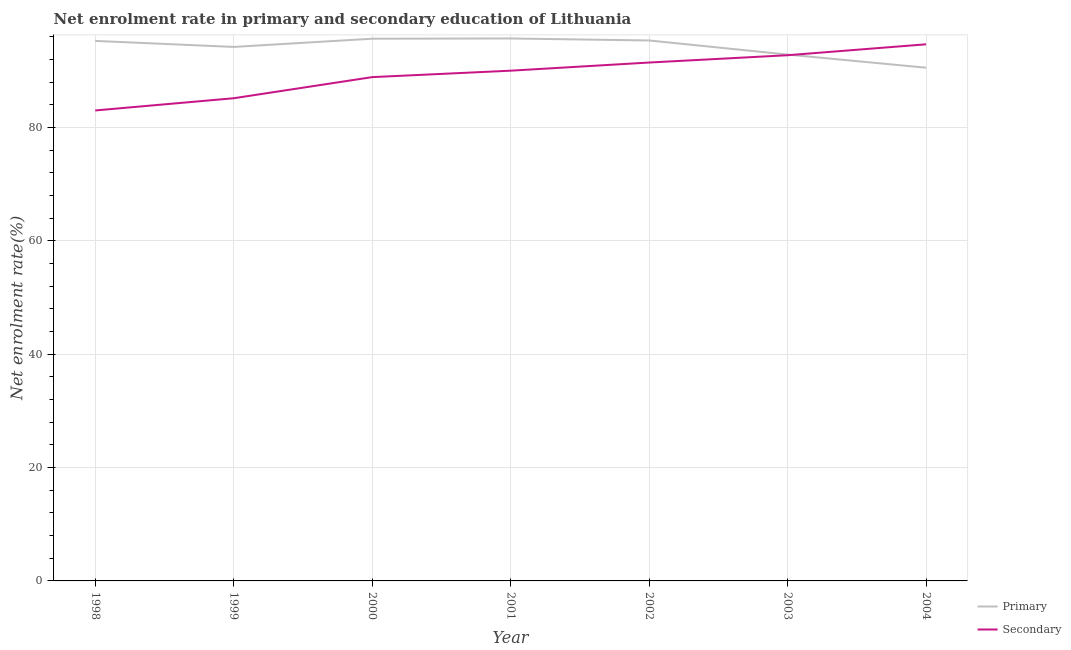Does the line corresponding to enrollment rate in primary education intersect with the line corresponding to enrollment rate in secondary education?
Give a very brief answer. Yes. Is the number of lines equal to the number of legend labels?
Keep it short and to the point. Yes. What is the enrollment rate in primary education in 2004?
Ensure brevity in your answer.  90.56. Across all years, what is the maximum enrollment rate in primary education?
Make the answer very short. 95.72. Across all years, what is the minimum enrollment rate in secondary education?
Your answer should be very brief. 83.02. In which year was the enrollment rate in primary education minimum?
Make the answer very short. 2004. What is the total enrollment rate in primary education in the graph?
Your answer should be very brief. 659.71. What is the difference between the enrollment rate in secondary education in 1999 and that in 2003?
Make the answer very short. -7.59. What is the difference between the enrollment rate in primary education in 1999 and the enrollment rate in secondary education in 2003?
Give a very brief answer. 1.46. What is the average enrollment rate in secondary education per year?
Make the answer very short. 89.44. In the year 1998, what is the difference between the enrollment rate in primary education and enrollment rate in secondary education?
Your answer should be very brief. 12.27. In how many years, is the enrollment rate in secondary education greater than 12 %?
Your response must be concise. 7. What is the ratio of the enrollment rate in primary education in 1998 to that in 1999?
Your answer should be compact. 1.01. Is the enrollment rate in secondary education in 2001 less than that in 2003?
Offer a very short reply. Yes. What is the difference between the highest and the second highest enrollment rate in secondary education?
Give a very brief answer. 1.93. What is the difference between the highest and the lowest enrollment rate in primary education?
Provide a short and direct response. 5.16. In how many years, is the enrollment rate in primary education greater than the average enrollment rate in primary education taken over all years?
Give a very brief answer. 4. Is the sum of the enrollment rate in secondary education in 2000 and 2004 greater than the maximum enrollment rate in primary education across all years?
Provide a succinct answer. Yes. Is the enrollment rate in secondary education strictly greater than the enrollment rate in primary education over the years?
Offer a terse response. No. Is the enrollment rate in secondary education strictly less than the enrollment rate in primary education over the years?
Your response must be concise. No. How many lines are there?
Offer a terse response. 2. How many years are there in the graph?
Give a very brief answer. 7. What is the difference between two consecutive major ticks on the Y-axis?
Offer a terse response. 20. Are the values on the major ticks of Y-axis written in scientific E-notation?
Provide a succinct answer. No. Does the graph contain any zero values?
Your answer should be very brief. No. How many legend labels are there?
Your answer should be compact. 2. What is the title of the graph?
Your answer should be very brief. Net enrolment rate in primary and secondary education of Lithuania. What is the label or title of the X-axis?
Give a very brief answer. Year. What is the label or title of the Y-axis?
Offer a terse response. Net enrolment rate(%). What is the Net enrolment rate(%) of Primary in 1998?
Give a very brief answer. 95.29. What is the Net enrolment rate(%) of Secondary in 1998?
Give a very brief answer. 83.02. What is the Net enrolment rate(%) of Primary in 1999?
Provide a short and direct response. 94.23. What is the Net enrolment rate(%) of Secondary in 1999?
Your answer should be compact. 85.17. What is the Net enrolment rate(%) of Primary in 2000?
Offer a very short reply. 95.68. What is the Net enrolment rate(%) of Secondary in 2000?
Keep it short and to the point. 88.9. What is the Net enrolment rate(%) of Primary in 2001?
Your response must be concise. 95.72. What is the Net enrolment rate(%) in Secondary in 2001?
Your response must be concise. 90.03. What is the Net enrolment rate(%) of Primary in 2002?
Your answer should be very brief. 95.37. What is the Net enrolment rate(%) in Secondary in 2002?
Offer a terse response. 91.47. What is the Net enrolment rate(%) in Primary in 2003?
Your answer should be compact. 92.88. What is the Net enrolment rate(%) of Secondary in 2003?
Offer a very short reply. 92.76. What is the Net enrolment rate(%) of Primary in 2004?
Offer a very short reply. 90.56. What is the Net enrolment rate(%) in Secondary in 2004?
Your answer should be compact. 94.69. Across all years, what is the maximum Net enrolment rate(%) in Primary?
Make the answer very short. 95.72. Across all years, what is the maximum Net enrolment rate(%) of Secondary?
Keep it short and to the point. 94.69. Across all years, what is the minimum Net enrolment rate(%) of Primary?
Your answer should be compact. 90.56. Across all years, what is the minimum Net enrolment rate(%) of Secondary?
Keep it short and to the point. 83.02. What is the total Net enrolment rate(%) in Primary in the graph?
Your response must be concise. 659.71. What is the total Net enrolment rate(%) of Secondary in the graph?
Your answer should be compact. 626.05. What is the difference between the Net enrolment rate(%) in Primary in 1998 and that in 1999?
Ensure brevity in your answer.  1.06. What is the difference between the Net enrolment rate(%) of Secondary in 1998 and that in 1999?
Offer a terse response. -2.16. What is the difference between the Net enrolment rate(%) in Primary in 1998 and that in 2000?
Ensure brevity in your answer.  -0.39. What is the difference between the Net enrolment rate(%) in Secondary in 1998 and that in 2000?
Offer a very short reply. -5.88. What is the difference between the Net enrolment rate(%) in Primary in 1998 and that in 2001?
Offer a very short reply. -0.43. What is the difference between the Net enrolment rate(%) in Secondary in 1998 and that in 2001?
Give a very brief answer. -7.02. What is the difference between the Net enrolment rate(%) of Primary in 1998 and that in 2002?
Your answer should be very brief. -0.08. What is the difference between the Net enrolment rate(%) in Secondary in 1998 and that in 2002?
Provide a succinct answer. -8.46. What is the difference between the Net enrolment rate(%) in Primary in 1998 and that in 2003?
Keep it short and to the point. 2.41. What is the difference between the Net enrolment rate(%) in Secondary in 1998 and that in 2003?
Ensure brevity in your answer.  -9.75. What is the difference between the Net enrolment rate(%) in Primary in 1998 and that in 2004?
Your answer should be very brief. 4.73. What is the difference between the Net enrolment rate(%) of Secondary in 1998 and that in 2004?
Provide a short and direct response. -11.67. What is the difference between the Net enrolment rate(%) in Primary in 1999 and that in 2000?
Offer a very short reply. -1.45. What is the difference between the Net enrolment rate(%) of Secondary in 1999 and that in 2000?
Provide a short and direct response. -3.73. What is the difference between the Net enrolment rate(%) of Primary in 1999 and that in 2001?
Ensure brevity in your answer.  -1.49. What is the difference between the Net enrolment rate(%) of Secondary in 1999 and that in 2001?
Make the answer very short. -4.86. What is the difference between the Net enrolment rate(%) of Primary in 1999 and that in 2002?
Your answer should be very brief. -1.14. What is the difference between the Net enrolment rate(%) of Secondary in 1999 and that in 2002?
Offer a terse response. -6.3. What is the difference between the Net enrolment rate(%) of Primary in 1999 and that in 2003?
Make the answer very short. 1.35. What is the difference between the Net enrolment rate(%) in Secondary in 1999 and that in 2003?
Ensure brevity in your answer.  -7.59. What is the difference between the Net enrolment rate(%) of Primary in 1999 and that in 2004?
Your answer should be very brief. 3.66. What is the difference between the Net enrolment rate(%) in Secondary in 1999 and that in 2004?
Keep it short and to the point. -9.52. What is the difference between the Net enrolment rate(%) in Primary in 2000 and that in 2001?
Provide a short and direct response. -0.04. What is the difference between the Net enrolment rate(%) in Secondary in 2000 and that in 2001?
Ensure brevity in your answer.  -1.14. What is the difference between the Net enrolment rate(%) in Primary in 2000 and that in 2002?
Your answer should be compact. 0.31. What is the difference between the Net enrolment rate(%) of Secondary in 2000 and that in 2002?
Your answer should be very brief. -2.57. What is the difference between the Net enrolment rate(%) of Primary in 2000 and that in 2003?
Provide a short and direct response. 2.8. What is the difference between the Net enrolment rate(%) in Secondary in 2000 and that in 2003?
Offer a terse response. -3.86. What is the difference between the Net enrolment rate(%) in Primary in 2000 and that in 2004?
Offer a terse response. 5.11. What is the difference between the Net enrolment rate(%) in Secondary in 2000 and that in 2004?
Ensure brevity in your answer.  -5.79. What is the difference between the Net enrolment rate(%) in Primary in 2001 and that in 2002?
Offer a very short reply. 0.35. What is the difference between the Net enrolment rate(%) in Secondary in 2001 and that in 2002?
Offer a terse response. -1.44. What is the difference between the Net enrolment rate(%) in Primary in 2001 and that in 2003?
Your answer should be compact. 2.84. What is the difference between the Net enrolment rate(%) in Secondary in 2001 and that in 2003?
Provide a short and direct response. -2.73. What is the difference between the Net enrolment rate(%) in Primary in 2001 and that in 2004?
Give a very brief answer. 5.16. What is the difference between the Net enrolment rate(%) of Secondary in 2001 and that in 2004?
Your response must be concise. -4.65. What is the difference between the Net enrolment rate(%) in Primary in 2002 and that in 2003?
Your answer should be very brief. 2.49. What is the difference between the Net enrolment rate(%) of Secondary in 2002 and that in 2003?
Your response must be concise. -1.29. What is the difference between the Net enrolment rate(%) in Primary in 2002 and that in 2004?
Give a very brief answer. 4.8. What is the difference between the Net enrolment rate(%) in Secondary in 2002 and that in 2004?
Provide a short and direct response. -3.22. What is the difference between the Net enrolment rate(%) of Primary in 2003 and that in 2004?
Provide a short and direct response. 2.32. What is the difference between the Net enrolment rate(%) in Secondary in 2003 and that in 2004?
Give a very brief answer. -1.93. What is the difference between the Net enrolment rate(%) of Primary in 1998 and the Net enrolment rate(%) of Secondary in 1999?
Offer a terse response. 10.11. What is the difference between the Net enrolment rate(%) in Primary in 1998 and the Net enrolment rate(%) in Secondary in 2000?
Provide a short and direct response. 6.39. What is the difference between the Net enrolment rate(%) in Primary in 1998 and the Net enrolment rate(%) in Secondary in 2001?
Keep it short and to the point. 5.25. What is the difference between the Net enrolment rate(%) of Primary in 1998 and the Net enrolment rate(%) of Secondary in 2002?
Provide a short and direct response. 3.81. What is the difference between the Net enrolment rate(%) in Primary in 1998 and the Net enrolment rate(%) in Secondary in 2003?
Your answer should be very brief. 2.52. What is the difference between the Net enrolment rate(%) in Primary in 1998 and the Net enrolment rate(%) in Secondary in 2004?
Provide a succinct answer. 0.6. What is the difference between the Net enrolment rate(%) of Primary in 1999 and the Net enrolment rate(%) of Secondary in 2000?
Provide a succinct answer. 5.33. What is the difference between the Net enrolment rate(%) of Primary in 1999 and the Net enrolment rate(%) of Secondary in 2001?
Offer a very short reply. 4.19. What is the difference between the Net enrolment rate(%) of Primary in 1999 and the Net enrolment rate(%) of Secondary in 2002?
Provide a short and direct response. 2.75. What is the difference between the Net enrolment rate(%) in Primary in 1999 and the Net enrolment rate(%) in Secondary in 2003?
Provide a short and direct response. 1.46. What is the difference between the Net enrolment rate(%) of Primary in 1999 and the Net enrolment rate(%) of Secondary in 2004?
Offer a terse response. -0.46. What is the difference between the Net enrolment rate(%) in Primary in 2000 and the Net enrolment rate(%) in Secondary in 2001?
Your answer should be compact. 5.64. What is the difference between the Net enrolment rate(%) of Primary in 2000 and the Net enrolment rate(%) of Secondary in 2002?
Ensure brevity in your answer.  4.2. What is the difference between the Net enrolment rate(%) of Primary in 2000 and the Net enrolment rate(%) of Secondary in 2003?
Provide a succinct answer. 2.91. What is the difference between the Net enrolment rate(%) of Primary in 2001 and the Net enrolment rate(%) of Secondary in 2002?
Make the answer very short. 4.25. What is the difference between the Net enrolment rate(%) in Primary in 2001 and the Net enrolment rate(%) in Secondary in 2003?
Give a very brief answer. 2.96. What is the difference between the Net enrolment rate(%) of Primary in 2001 and the Net enrolment rate(%) of Secondary in 2004?
Provide a succinct answer. 1.03. What is the difference between the Net enrolment rate(%) in Primary in 2002 and the Net enrolment rate(%) in Secondary in 2003?
Provide a short and direct response. 2.6. What is the difference between the Net enrolment rate(%) in Primary in 2002 and the Net enrolment rate(%) in Secondary in 2004?
Make the answer very short. 0.68. What is the difference between the Net enrolment rate(%) of Primary in 2003 and the Net enrolment rate(%) of Secondary in 2004?
Ensure brevity in your answer.  -1.81. What is the average Net enrolment rate(%) in Primary per year?
Give a very brief answer. 94.24. What is the average Net enrolment rate(%) of Secondary per year?
Give a very brief answer. 89.44. In the year 1998, what is the difference between the Net enrolment rate(%) of Primary and Net enrolment rate(%) of Secondary?
Give a very brief answer. 12.27. In the year 1999, what is the difference between the Net enrolment rate(%) in Primary and Net enrolment rate(%) in Secondary?
Keep it short and to the point. 9.05. In the year 2000, what is the difference between the Net enrolment rate(%) in Primary and Net enrolment rate(%) in Secondary?
Offer a very short reply. 6.78. In the year 2001, what is the difference between the Net enrolment rate(%) in Primary and Net enrolment rate(%) in Secondary?
Ensure brevity in your answer.  5.68. In the year 2002, what is the difference between the Net enrolment rate(%) of Primary and Net enrolment rate(%) of Secondary?
Keep it short and to the point. 3.89. In the year 2003, what is the difference between the Net enrolment rate(%) in Primary and Net enrolment rate(%) in Secondary?
Make the answer very short. 0.12. In the year 2004, what is the difference between the Net enrolment rate(%) of Primary and Net enrolment rate(%) of Secondary?
Give a very brief answer. -4.13. What is the ratio of the Net enrolment rate(%) in Primary in 1998 to that in 1999?
Offer a very short reply. 1.01. What is the ratio of the Net enrolment rate(%) of Secondary in 1998 to that in 1999?
Your answer should be very brief. 0.97. What is the ratio of the Net enrolment rate(%) of Secondary in 1998 to that in 2000?
Provide a succinct answer. 0.93. What is the ratio of the Net enrolment rate(%) of Secondary in 1998 to that in 2001?
Offer a terse response. 0.92. What is the ratio of the Net enrolment rate(%) in Secondary in 1998 to that in 2002?
Make the answer very short. 0.91. What is the ratio of the Net enrolment rate(%) in Primary in 1998 to that in 2003?
Ensure brevity in your answer.  1.03. What is the ratio of the Net enrolment rate(%) of Secondary in 1998 to that in 2003?
Offer a very short reply. 0.89. What is the ratio of the Net enrolment rate(%) of Primary in 1998 to that in 2004?
Ensure brevity in your answer.  1.05. What is the ratio of the Net enrolment rate(%) of Secondary in 1998 to that in 2004?
Ensure brevity in your answer.  0.88. What is the ratio of the Net enrolment rate(%) of Primary in 1999 to that in 2000?
Keep it short and to the point. 0.98. What is the ratio of the Net enrolment rate(%) of Secondary in 1999 to that in 2000?
Make the answer very short. 0.96. What is the ratio of the Net enrolment rate(%) of Primary in 1999 to that in 2001?
Keep it short and to the point. 0.98. What is the ratio of the Net enrolment rate(%) in Secondary in 1999 to that in 2001?
Your response must be concise. 0.95. What is the ratio of the Net enrolment rate(%) in Primary in 1999 to that in 2002?
Offer a terse response. 0.99. What is the ratio of the Net enrolment rate(%) in Secondary in 1999 to that in 2002?
Your answer should be compact. 0.93. What is the ratio of the Net enrolment rate(%) in Primary in 1999 to that in 2003?
Provide a succinct answer. 1.01. What is the ratio of the Net enrolment rate(%) of Secondary in 1999 to that in 2003?
Your answer should be very brief. 0.92. What is the ratio of the Net enrolment rate(%) in Primary in 1999 to that in 2004?
Your answer should be very brief. 1.04. What is the ratio of the Net enrolment rate(%) of Secondary in 1999 to that in 2004?
Make the answer very short. 0.9. What is the ratio of the Net enrolment rate(%) in Primary in 2000 to that in 2001?
Your answer should be very brief. 1. What is the ratio of the Net enrolment rate(%) in Secondary in 2000 to that in 2001?
Make the answer very short. 0.99. What is the ratio of the Net enrolment rate(%) of Primary in 2000 to that in 2002?
Provide a succinct answer. 1. What is the ratio of the Net enrolment rate(%) in Secondary in 2000 to that in 2002?
Make the answer very short. 0.97. What is the ratio of the Net enrolment rate(%) of Primary in 2000 to that in 2003?
Provide a short and direct response. 1.03. What is the ratio of the Net enrolment rate(%) in Secondary in 2000 to that in 2003?
Give a very brief answer. 0.96. What is the ratio of the Net enrolment rate(%) in Primary in 2000 to that in 2004?
Offer a very short reply. 1.06. What is the ratio of the Net enrolment rate(%) of Secondary in 2000 to that in 2004?
Your answer should be very brief. 0.94. What is the ratio of the Net enrolment rate(%) in Secondary in 2001 to that in 2002?
Offer a terse response. 0.98. What is the ratio of the Net enrolment rate(%) in Primary in 2001 to that in 2003?
Offer a very short reply. 1.03. What is the ratio of the Net enrolment rate(%) of Secondary in 2001 to that in 2003?
Ensure brevity in your answer.  0.97. What is the ratio of the Net enrolment rate(%) in Primary in 2001 to that in 2004?
Your answer should be compact. 1.06. What is the ratio of the Net enrolment rate(%) in Secondary in 2001 to that in 2004?
Your response must be concise. 0.95. What is the ratio of the Net enrolment rate(%) of Primary in 2002 to that in 2003?
Your answer should be very brief. 1.03. What is the ratio of the Net enrolment rate(%) in Secondary in 2002 to that in 2003?
Give a very brief answer. 0.99. What is the ratio of the Net enrolment rate(%) in Primary in 2002 to that in 2004?
Give a very brief answer. 1.05. What is the ratio of the Net enrolment rate(%) of Primary in 2003 to that in 2004?
Give a very brief answer. 1.03. What is the ratio of the Net enrolment rate(%) of Secondary in 2003 to that in 2004?
Give a very brief answer. 0.98. What is the difference between the highest and the second highest Net enrolment rate(%) of Primary?
Make the answer very short. 0.04. What is the difference between the highest and the second highest Net enrolment rate(%) of Secondary?
Your response must be concise. 1.93. What is the difference between the highest and the lowest Net enrolment rate(%) of Primary?
Provide a short and direct response. 5.16. What is the difference between the highest and the lowest Net enrolment rate(%) in Secondary?
Your answer should be very brief. 11.67. 